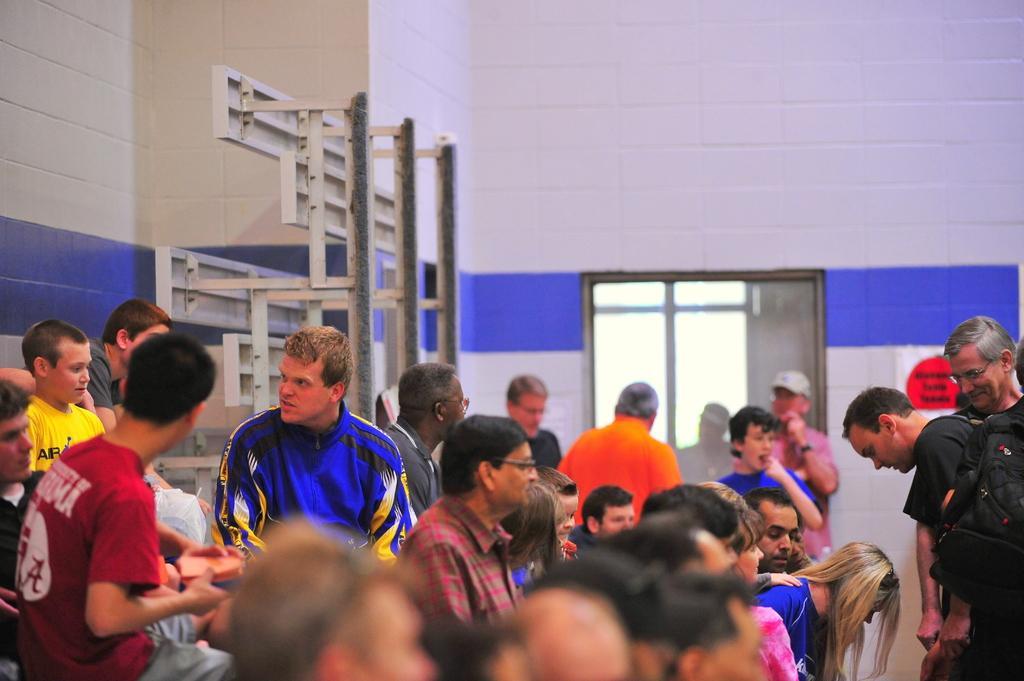Please provide a concise description of this image. In this image we can see group of people sitting. To the right side of the image we can see some persons standing and a person is wearing a bag. In the background we can see a person wearing cap is standing near to a window. 